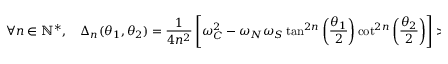Convert formula to latex. <formula><loc_0><loc_0><loc_500><loc_500>\forall n \in \mathbb { N } ^ { * } , \quad \Delta _ { n } ( \theta _ { 1 } , \theta _ { 2 } ) = \frac { 1 } { 4 n ^ { 2 } } \left [ \omega _ { C } ^ { 2 } - \omega _ { N } \omega _ { S } \tan ^ { 2 n } \left ( \frac { \theta _ { 1 } } { 2 } \right ) \cot ^ { 2 n } \left ( \frac { \theta _ { 2 } } { 2 } \right ) \right ] > 0 .</formula> 